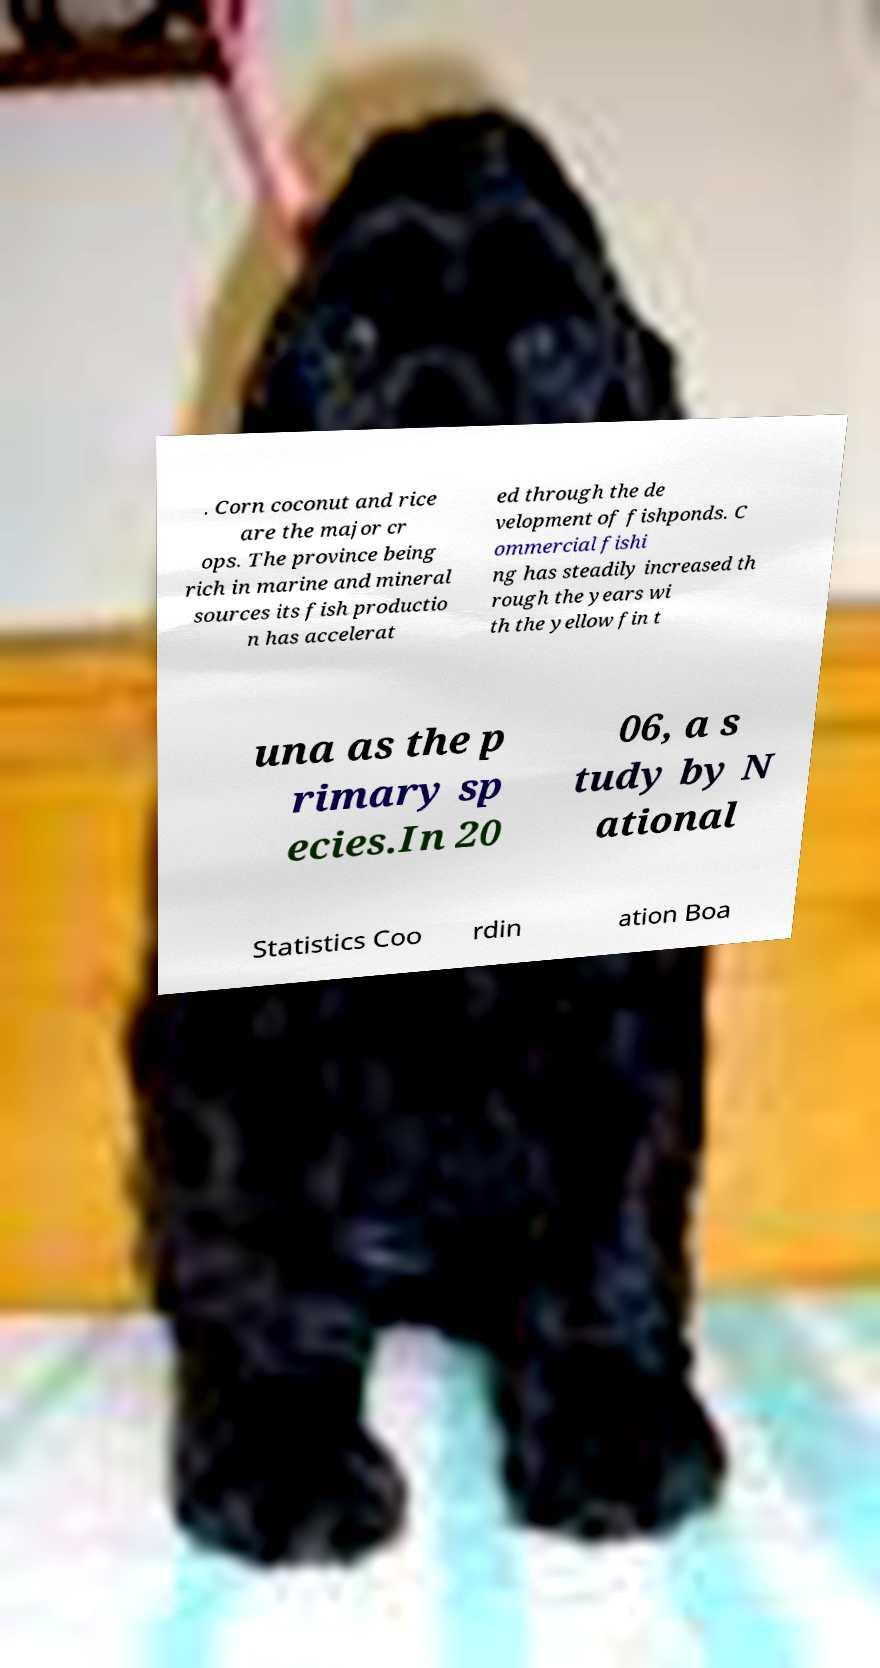Please identify and transcribe the text found in this image. . Corn coconut and rice are the major cr ops. The province being rich in marine and mineral sources its fish productio n has accelerat ed through the de velopment of fishponds. C ommercial fishi ng has steadily increased th rough the years wi th the yellow fin t una as the p rimary sp ecies.In 20 06, a s tudy by N ational Statistics Coo rdin ation Boa 